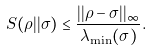Convert formula to latex. <formula><loc_0><loc_0><loc_500><loc_500>S ( \rho | | \sigma ) \leq \frac { | | \rho - \sigma | | _ { \infty } } { \lambda _ { \min } ( \sigma ) } .</formula> 